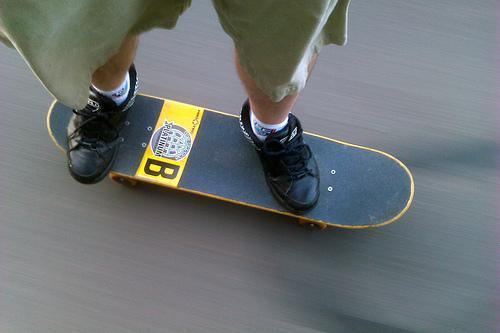How many shoes are on the board?
Give a very brief answer. 2. 